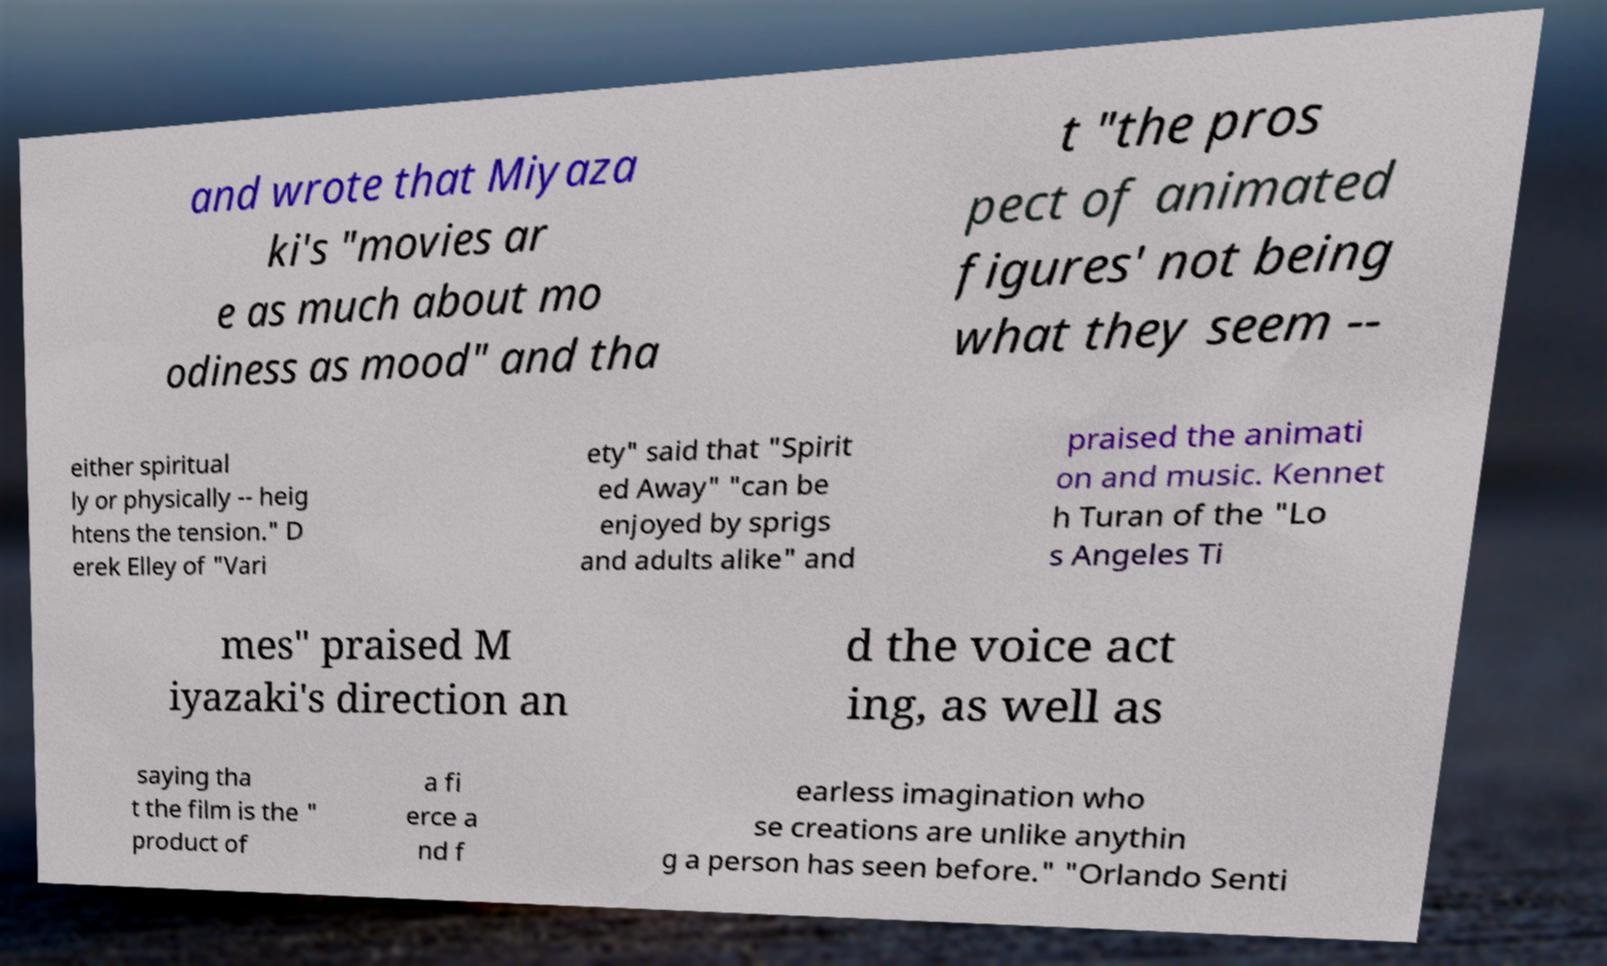For documentation purposes, I need the text within this image transcribed. Could you provide that? and wrote that Miyaza ki's "movies ar e as much about mo odiness as mood" and tha t "the pros pect of animated figures' not being what they seem -- either spiritual ly or physically -- heig htens the tension." D erek Elley of "Vari ety" said that "Spirit ed Away" "can be enjoyed by sprigs and adults alike" and praised the animati on and music. Kennet h Turan of the "Lo s Angeles Ti mes" praised M iyazaki's direction an d the voice act ing, as well as saying tha t the film is the " product of a fi erce a nd f earless imagination who se creations are unlike anythin g a person has seen before." "Orlando Senti 